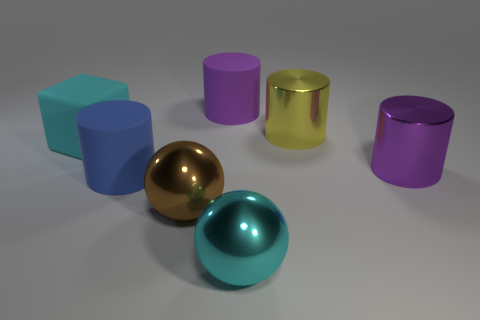How many shiny objects are either purple objects or cyan blocks?
Ensure brevity in your answer.  1. There is a big purple cylinder to the left of the purple cylinder that is on the right side of the cyan object that is in front of the large blue rubber cylinder; what is its material?
Your response must be concise. Rubber. There is a big cyan object in front of the cube; is its shape the same as the cyan thing behind the big brown thing?
Ensure brevity in your answer.  No. There is a sphere in front of the large shiny ball behind the big cyan shiny ball; what is its color?
Offer a very short reply. Cyan. How many cylinders are tiny red matte things or large purple things?
Keep it short and to the point. 2. How many cubes are to the right of the purple cylinder to the right of the cyan thing to the right of the brown sphere?
Your response must be concise. 0. What is the size of the sphere that is the same color as the large block?
Your answer should be compact. Large. Is there a purple thing made of the same material as the large blue thing?
Offer a terse response. Yes. Are the yellow object and the big brown sphere made of the same material?
Provide a succinct answer. Yes. What number of big matte objects are to the left of the large purple cylinder to the left of the purple shiny cylinder?
Make the answer very short. 2. 